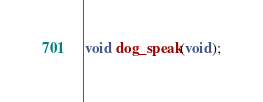<code> <loc_0><loc_0><loc_500><loc_500><_C_>void dog_speak(void);
</code> 